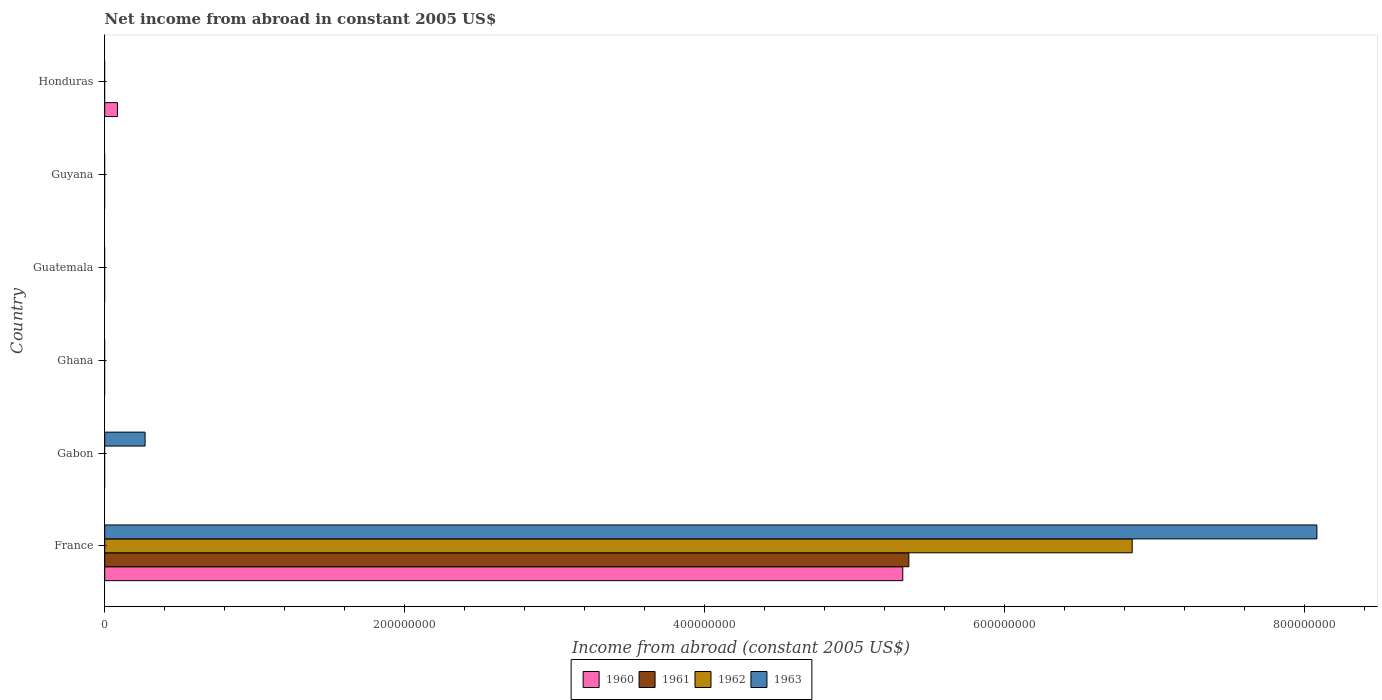How many different coloured bars are there?
Make the answer very short. 4. Are the number of bars on each tick of the Y-axis equal?
Provide a succinct answer. No. How many bars are there on the 3rd tick from the bottom?
Ensure brevity in your answer.  0. What is the label of the 1st group of bars from the top?
Your response must be concise. Honduras. In how many cases, is the number of bars for a given country not equal to the number of legend labels?
Your answer should be compact. 5. Across all countries, what is the maximum net income from abroad in 1960?
Offer a terse response. 5.32e+08. In which country was the net income from abroad in 1963 maximum?
Make the answer very short. France. What is the total net income from abroad in 1963 in the graph?
Ensure brevity in your answer.  8.35e+08. What is the average net income from abroad in 1960 per country?
Ensure brevity in your answer.  9.01e+07. Is the net income from abroad in 1963 in France less than that in Gabon?
Offer a terse response. No. What is the difference between the highest and the lowest net income from abroad in 1962?
Offer a very short reply. 6.85e+08. Is it the case that in every country, the sum of the net income from abroad in 1962 and net income from abroad in 1960 is greater than the sum of net income from abroad in 1961 and net income from abroad in 1963?
Make the answer very short. No. Is it the case that in every country, the sum of the net income from abroad in 1963 and net income from abroad in 1960 is greater than the net income from abroad in 1961?
Give a very brief answer. No. How many bars are there?
Your answer should be compact. 6. Does the graph contain any zero values?
Ensure brevity in your answer.  Yes. Does the graph contain grids?
Offer a very short reply. No. How are the legend labels stacked?
Ensure brevity in your answer.  Horizontal. What is the title of the graph?
Your answer should be compact. Net income from abroad in constant 2005 US$. What is the label or title of the X-axis?
Provide a succinct answer. Income from abroad (constant 2005 US$). What is the label or title of the Y-axis?
Offer a terse response. Country. What is the Income from abroad (constant 2005 US$) in 1960 in France?
Ensure brevity in your answer.  5.32e+08. What is the Income from abroad (constant 2005 US$) in 1961 in France?
Ensure brevity in your answer.  5.36e+08. What is the Income from abroad (constant 2005 US$) of 1962 in France?
Ensure brevity in your answer.  6.85e+08. What is the Income from abroad (constant 2005 US$) in 1963 in France?
Offer a terse response. 8.08e+08. What is the Income from abroad (constant 2005 US$) in 1961 in Gabon?
Make the answer very short. 0. What is the Income from abroad (constant 2005 US$) of 1963 in Gabon?
Keep it short and to the point. 2.69e+07. What is the Income from abroad (constant 2005 US$) in 1960 in Ghana?
Your answer should be very brief. 0. What is the Income from abroad (constant 2005 US$) of 1961 in Ghana?
Your answer should be compact. 0. What is the Income from abroad (constant 2005 US$) in 1961 in Guatemala?
Give a very brief answer. 0. What is the Income from abroad (constant 2005 US$) in 1961 in Guyana?
Make the answer very short. 0. What is the Income from abroad (constant 2005 US$) in 1963 in Guyana?
Offer a terse response. 0. What is the Income from abroad (constant 2005 US$) of 1960 in Honduras?
Your answer should be very brief. 8.50e+06. What is the Income from abroad (constant 2005 US$) of 1961 in Honduras?
Offer a terse response. 0. Across all countries, what is the maximum Income from abroad (constant 2005 US$) of 1960?
Your response must be concise. 5.32e+08. Across all countries, what is the maximum Income from abroad (constant 2005 US$) of 1961?
Offer a very short reply. 5.36e+08. Across all countries, what is the maximum Income from abroad (constant 2005 US$) in 1962?
Ensure brevity in your answer.  6.85e+08. Across all countries, what is the maximum Income from abroad (constant 2005 US$) of 1963?
Provide a succinct answer. 8.08e+08. Across all countries, what is the minimum Income from abroad (constant 2005 US$) in 1960?
Ensure brevity in your answer.  0. What is the total Income from abroad (constant 2005 US$) in 1960 in the graph?
Give a very brief answer. 5.41e+08. What is the total Income from abroad (constant 2005 US$) in 1961 in the graph?
Offer a very short reply. 5.36e+08. What is the total Income from abroad (constant 2005 US$) of 1962 in the graph?
Provide a short and direct response. 6.85e+08. What is the total Income from abroad (constant 2005 US$) of 1963 in the graph?
Your answer should be very brief. 8.35e+08. What is the difference between the Income from abroad (constant 2005 US$) of 1963 in France and that in Gabon?
Your response must be concise. 7.81e+08. What is the difference between the Income from abroad (constant 2005 US$) in 1960 in France and that in Honduras?
Ensure brevity in your answer.  5.24e+08. What is the difference between the Income from abroad (constant 2005 US$) of 1960 in France and the Income from abroad (constant 2005 US$) of 1963 in Gabon?
Make the answer very short. 5.05e+08. What is the difference between the Income from abroad (constant 2005 US$) of 1961 in France and the Income from abroad (constant 2005 US$) of 1963 in Gabon?
Offer a terse response. 5.09e+08. What is the difference between the Income from abroad (constant 2005 US$) of 1962 in France and the Income from abroad (constant 2005 US$) of 1963 in Gabon?
Give a very brief answer. 6.58e+08. What is the average Income from abroad (constant 2005 US$) of 1960 per country?
Provide a succinct answer. 9.01e+07. What is the average Income from abroad (constant 2005 US$) of 1961 per country?
Keep it short and to the point. 8.94e+07. What is the average Income from abroad (constant 2005 US$) in 1962 per country?
Keep it short and to the point. 1.14e+08. What is the average Income from abroad (constant 2005 US$) in 1963 per country?
Ensure brevity in your answer.  1.39e+08. What is the difference between the Income from abroad (constant 2005 US$) of 1960 and Income from abroad (constant 2005 US$) of 1961 in France?
Make the answer very short. -4.05e+06. What is the difference between the Income from abroad (constant 2005 US$) in 1960 and Income from abroad (constant 2005 US$) in 1962 in France?
Provide a short and direct response. -1.53e+08. What is the difference between the Income from abroad (constant 2005 US$) of 1960 and Income from abroad (constant 2005 US$) of 1963 in France?
Ensure brevity in your answer.  -2.76e+08. What is the difference between the Income from abroad (constant 2005 US$) in 1961 and Income from abroad (constant 2005 US$) in 1962 in France?
Give a very brief answer. -1.49e+08. What is the difference between the Income from abroad (constant 2005 US$) of 1961 and Income from abroad (constant 2005 US$) of 1963 in France?
Offer a very short reply. -2.72e+08. What is the difference between the Income from abroad (constant 2005 US$) in 1962 and Income from abroad (constant 2005 US$) in 1963 in France?
Offer a very short reply. -1.23e+08. What is the ratio of the Income from abroad (constant 2005 US$) in 1963 in France to that in Gabon?
Provide a succinct answer. 30.04. What is the ratio of the Income from abroad (constant 2005 US$) in 1960 in France to that in Honduras?
Make the answer very short. 62.61. What is the difference between the highest and the lowest Income from abroad (constant 2005 US$) in 1960?
Your answer should be very brief. 5.32e+08. What is the difference between the highest and the lowest Income from abroad (constant 2005 US$) in 1961?
Offer a terse response. 5.36e+08. What is the difference between the highest and the lowest Income from abroad (constant 2005 US$) of 1962?
Your answer should be compact. 6.85e+08. What is the difference between the highest and the lowest Income from abroad (constant 2005 US$) in 1963?
Offer a very short reply. 8.08e+08. 